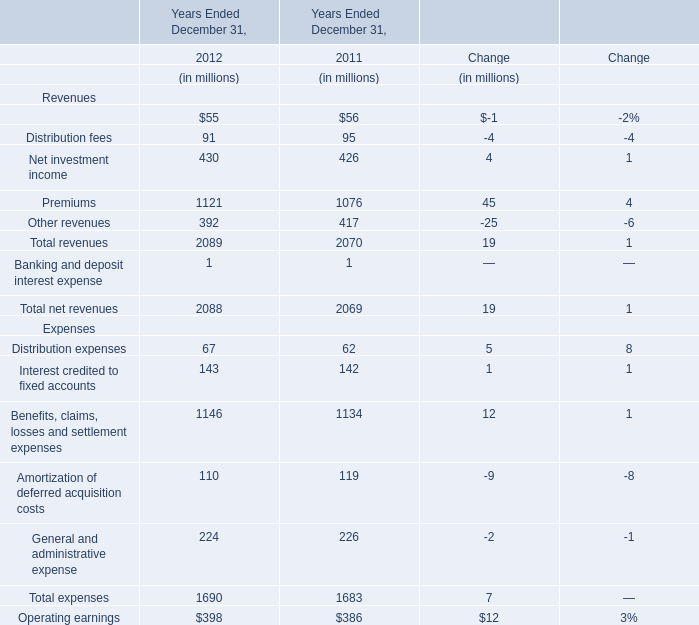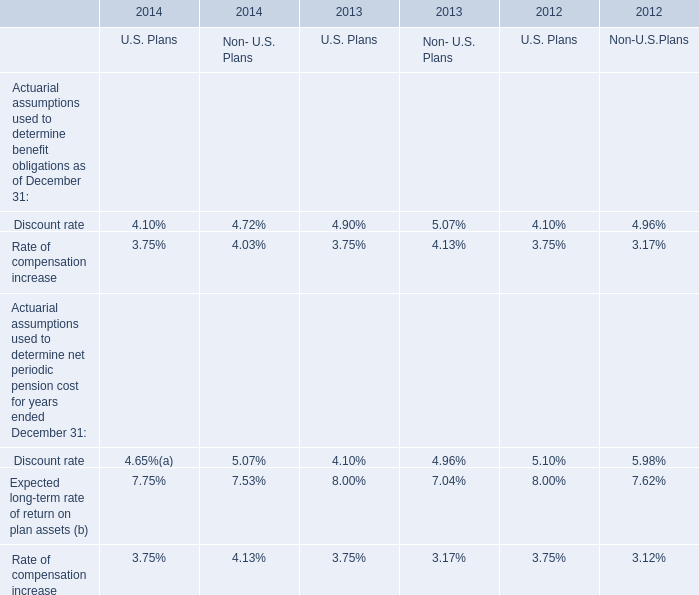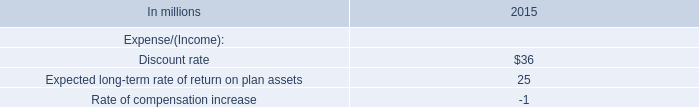What's the sum of the Net investment income in the years where Distribution fees is greater than 91? 
Answer: 426. 